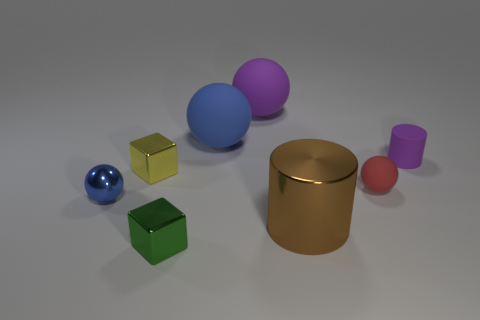Are there any patterns or repetition in this image? Yes, there is a repetition of shapes; there are two spheres and two cubes featured, which shows a pattern in the variety of geometric forms present. 